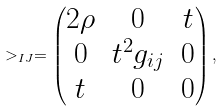<formula> <loc_0><loc_0><loc_500><loc_500>> _ { I J } = \left ( \begin{matrix} 2 \rho & 0 & t \\ 0 & t ^ { 2 } g _ { i j } & 0 \\ t & 0 & 0 \end{matrix} \right ) ,</formula> 